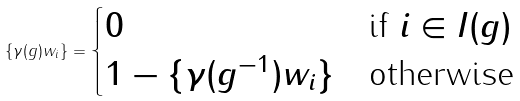<formula> <loc_0><loc_0><loc_500><loc_500>\{ \gamma ( g ) w _ { i } \} = \begin{cases} 0 & \text {if } i \in I ( g ) \\ 1 - \{ \gamma ( g ^ { - 1 } ) w _ { i } \} & \text {otherwise} \end{cases}</formula> 